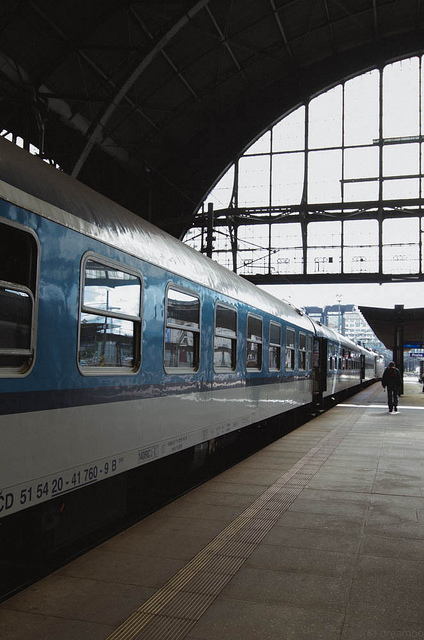Identify and read out the text in this image. CD 51 54 420 1760 8 9 41 